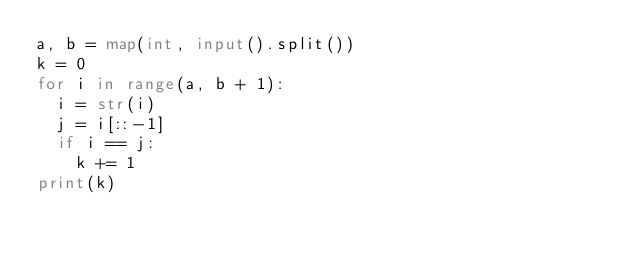<code> <loc_0><loc_0><loc_500><loc_500><_Python_>a, b = map(int, input().split())
k = 0
for i in range(a, b + 1):
  i = str(i)
  j = i[::-1]
  if i == j:
    k += 1
print(k)</code> 